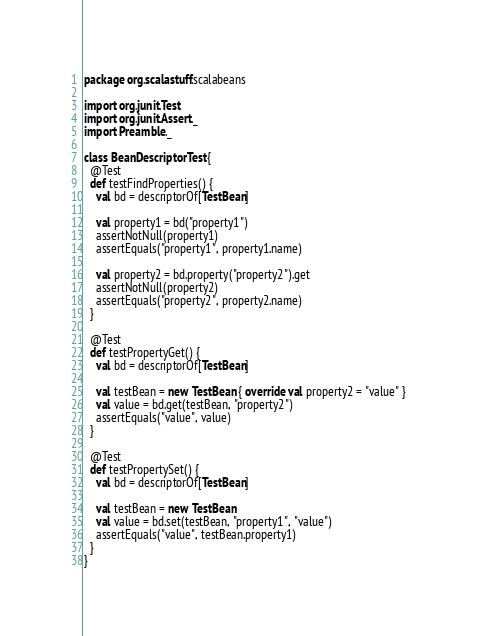<code> <loc_0><loc_0><loc_500><loc_500><_Scala_>package org.scalastuff.scalabeans

import org.junit.Test
import org.junit.Assert._
import Preamble._

class BeanDescriptorTest {
  @Test
  def testFindProperties() {
    val bd = descriptorOf[TestBean]
    
    val property1 = bd("property1")
    assertNotNull(property1)
    assertEquals("property1", property1.name)
    
    val property2 = bd.property("property2").get
    assertNotNull(property2)
    assertEquals("property2", property2.name)
  }
  
  @Test
  def testPropertyGet() {
    val bd = descriptorOf[TestBean]
    
    val testBean = new TestBean { override val property2 = "value" }
    val value = bd.get(testBean, "property2")
    assertEquals("value", value)
  }
  
  @Test
  def testPropertySet() {
    val bd = descriptorOf[TestBean]
    
    val testBean = new TestBean
    val value = bd.set(testBean, "property1", "value")
    assertEquals("value", testBean.property1)
  }
}</code> 